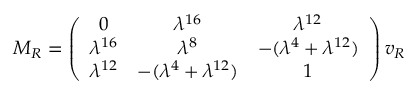<formula> <loc_0><loc_0><loc_500><loc_500>M _ { R } = \left ( \begin{array} { c c c } { 0 } & { { \lambda ^ { 1 6 } } } & { { \lambda ^ { 1 2 } } } \\ { { \lambda ^ { 1 6 } } } & { { \lambda ^ { 8 } } } & { { - ( \lambda ^ { 4 } + \lambda ^ { 1 2 } ) } } \\ { { \lambda ^ { 1 2 } } } & { { - ( \lambda ^ { 4 } + \lambda ^ { 1 2 } ) } } & { 1 } \end{array} \right ) v _ { R }</formula> 